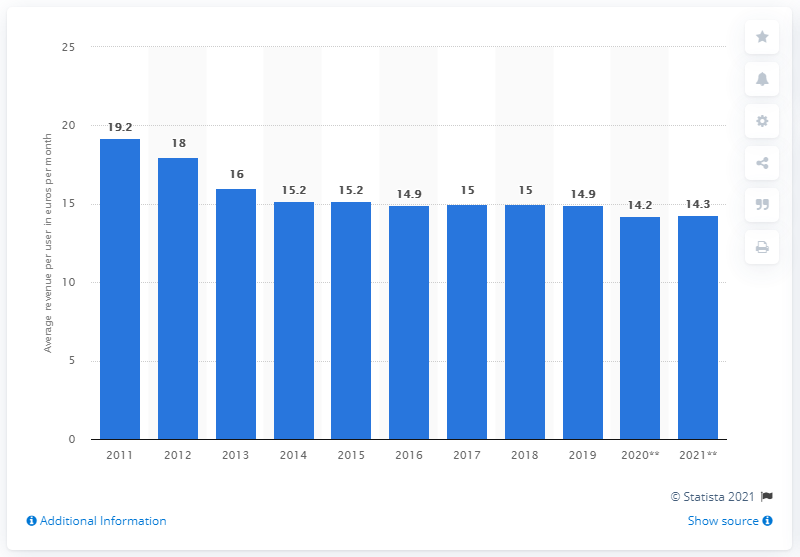What is the projected revenue per user of mobile broadband customers in Europe by 2021? Based on the bar chart, the projected average revenue per user of mobile broadband customers in Europe by 2021 was estimated to be €14.3 per month. This reflects a slight decrease from the €14.2 reported in 2020, continuing the overall downward trend observed since 2011. 